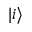Convert formula to latex. <formula><loc_0><loc_0><loc_500><loc_500>| i \rangle</formula> 